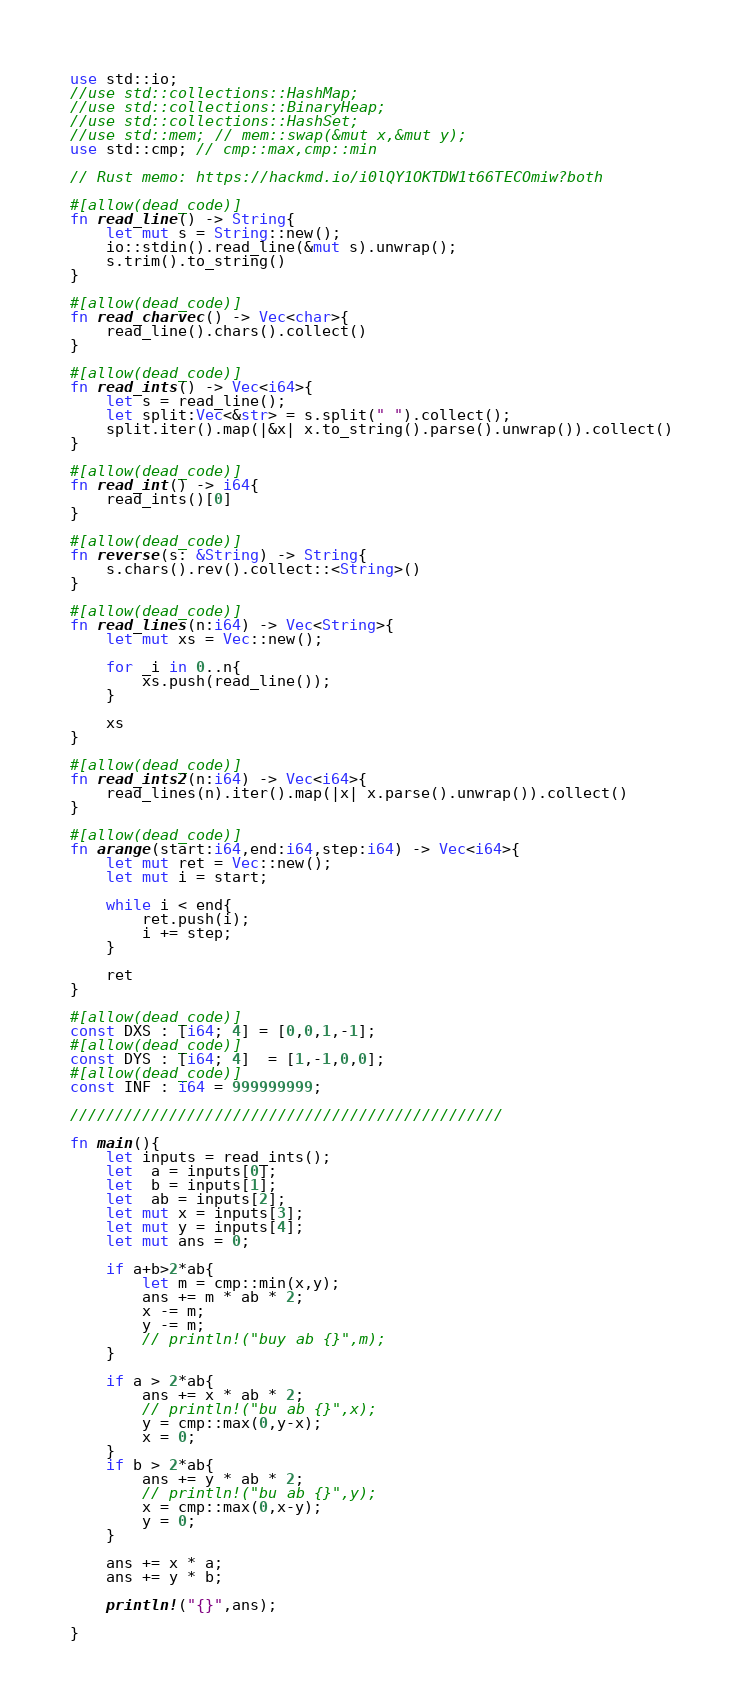<code> <loc_0><loc_0><loc_500><loc_500><_Rust_>use std::io;
//use std::collections::HashMap;
//use std::collections::BinaryHeap;
//use std::collections::HashSet;
//use std::mem; // mem::swap(&mut x,&mut y);
use std::cmp; // cmp::max,cmp::min

// Rust memo: https://hackmd.io/i0lQY1OKTDW1t66TECOmiw?both

#[allow(dead_code)]
fn read_line() -> String{
    let mut s = String::new();
    io::stdin().read_line(&mut s).unwrap();
    s.trim().to_string()
}

#[allow(dead_code)]
fn read_charvec() -> Vec<char>{
    read_line().chars().collect()
}

#[allow(dead_code)]
fn read_ints() -> Vec<i64>{
    let s = read_line();
    let split:Vec<&str> = s.split(" ").collect();
    split.iter().map(|&x| x.to_string().parse().unwrap()).collect()
}

#[allow(dead_code)]
fn read_int() -> i64{
    read_ints()[0]
}

#[allow(dead_code)]
fn reverse(s: &String) -> String{
    s.chars().rev().collect::<String>()
}

#[allow(dead_code)]
fn read_lines(n:i64) -> Vec<String>{
    let mut xs = Vec::new();

    for _i in 0..n{
        xs.push(read_line());
    }

    xs
}

#[allow(dead_code)]
fn read_ints2(n:i64) -> Vec<i64>{
    read_lines(n).iter().map(|x| x.parse().unwrap()).collect()
}

#[allow(dead_code)]
fn arange(start:i64,end:i64,step:i64) -> Vec<i64>{
    let mut ret = Vec::new();
    let mut i = start;

    while i < end{
        ret.push(i);
        i += step;
    }

    ret
}

#[allow(dead_code)]
const DXS : [i64; 4] = [0,0,1,-1];
#[allow(dead_code)]
const DYS : [i64; 4]  = [1,-1,0,0];
#[allow(dead_code)]
const INF : i64 = 999999999;

////////////////////////////////////////////////

fn main(){
    let inputs = read_ints();
    let  a = inputs[0];
    let  b = inputs[1];
    let  ab = inputs[2];
    let mut x = inputs[3];
    let mut y = inputs[4];
    let mut ans = 0;
    
    if a+b>2*ab{
        let m = cmp::min(x,y);
        ans += m * ab * 2;
        x -= m;
        y -= m;
        // println!("buy ab {}",m);
    }

    if a > 2*ab{
        ans += x * ab * 2;
        // println!("bu ab {}",x);
        y = cmp::max(0,y-x);
        x = 0;
    }
    if b > 2*ab{
        ans += y * ab * 2;
        // println!("bu ab {}",y);
        x = cmp::max(0,x-y);
        y = 0;
    }

    ans += x * a;
    ans += y * b;

    println!("{}",ans);

}</code> 